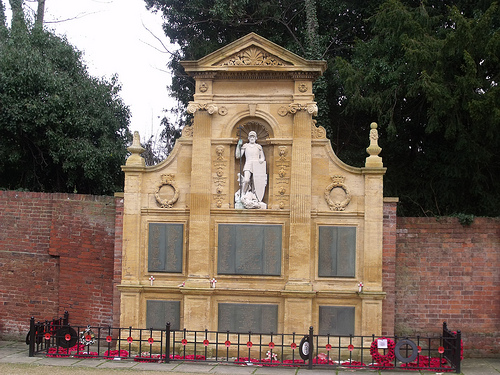<image>
Can you confirm if the building is next to the tree? Yes. The building is positioned adjacent to the tree, located nearby in the same general area. 